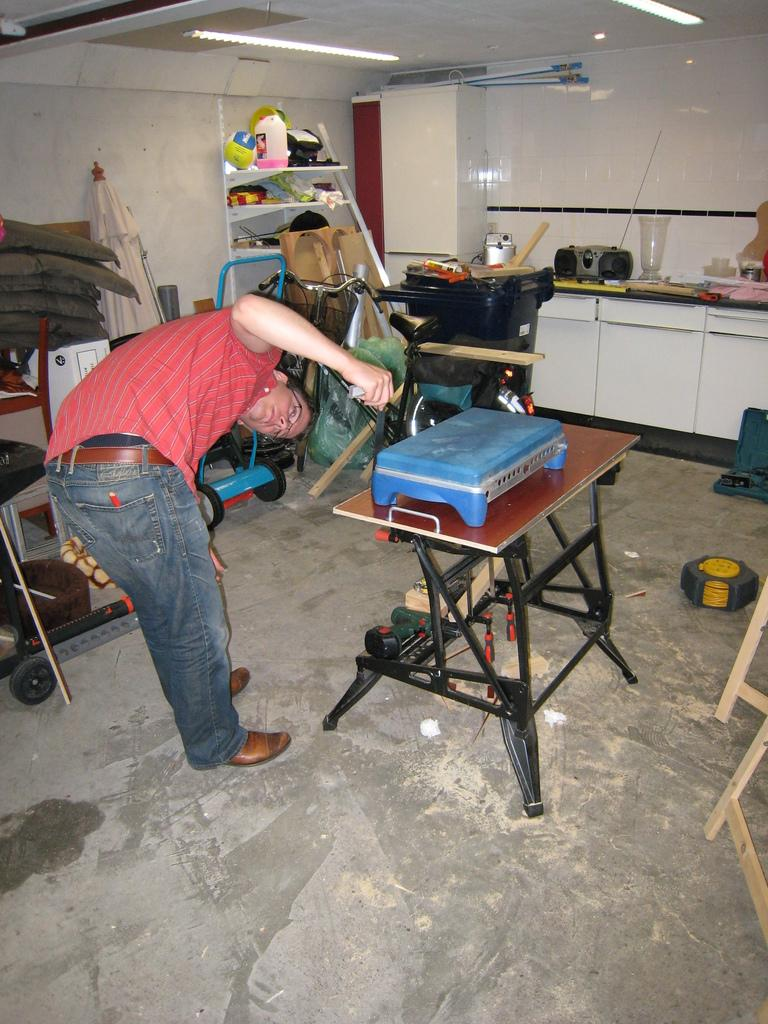Who is present in the image? There is a man in the image. What is the man wearing? The man is wearing a red shirt. What type of furniture can be seen in the image? There is a table in the image. What is the background of the image? There is a wall in the image. What can be seen illuminating the scene? There are lights in the image. What type of plantation can be seen in the image? There is no plantation present in the image. 